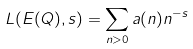Convert formula to latex. <formula><loc_0><loc_0><loc_500><loc_500>L ( E ( Q ) , s ) = \sum _ { n > 0 } a ( n ) n ^ { - s }</formula> 